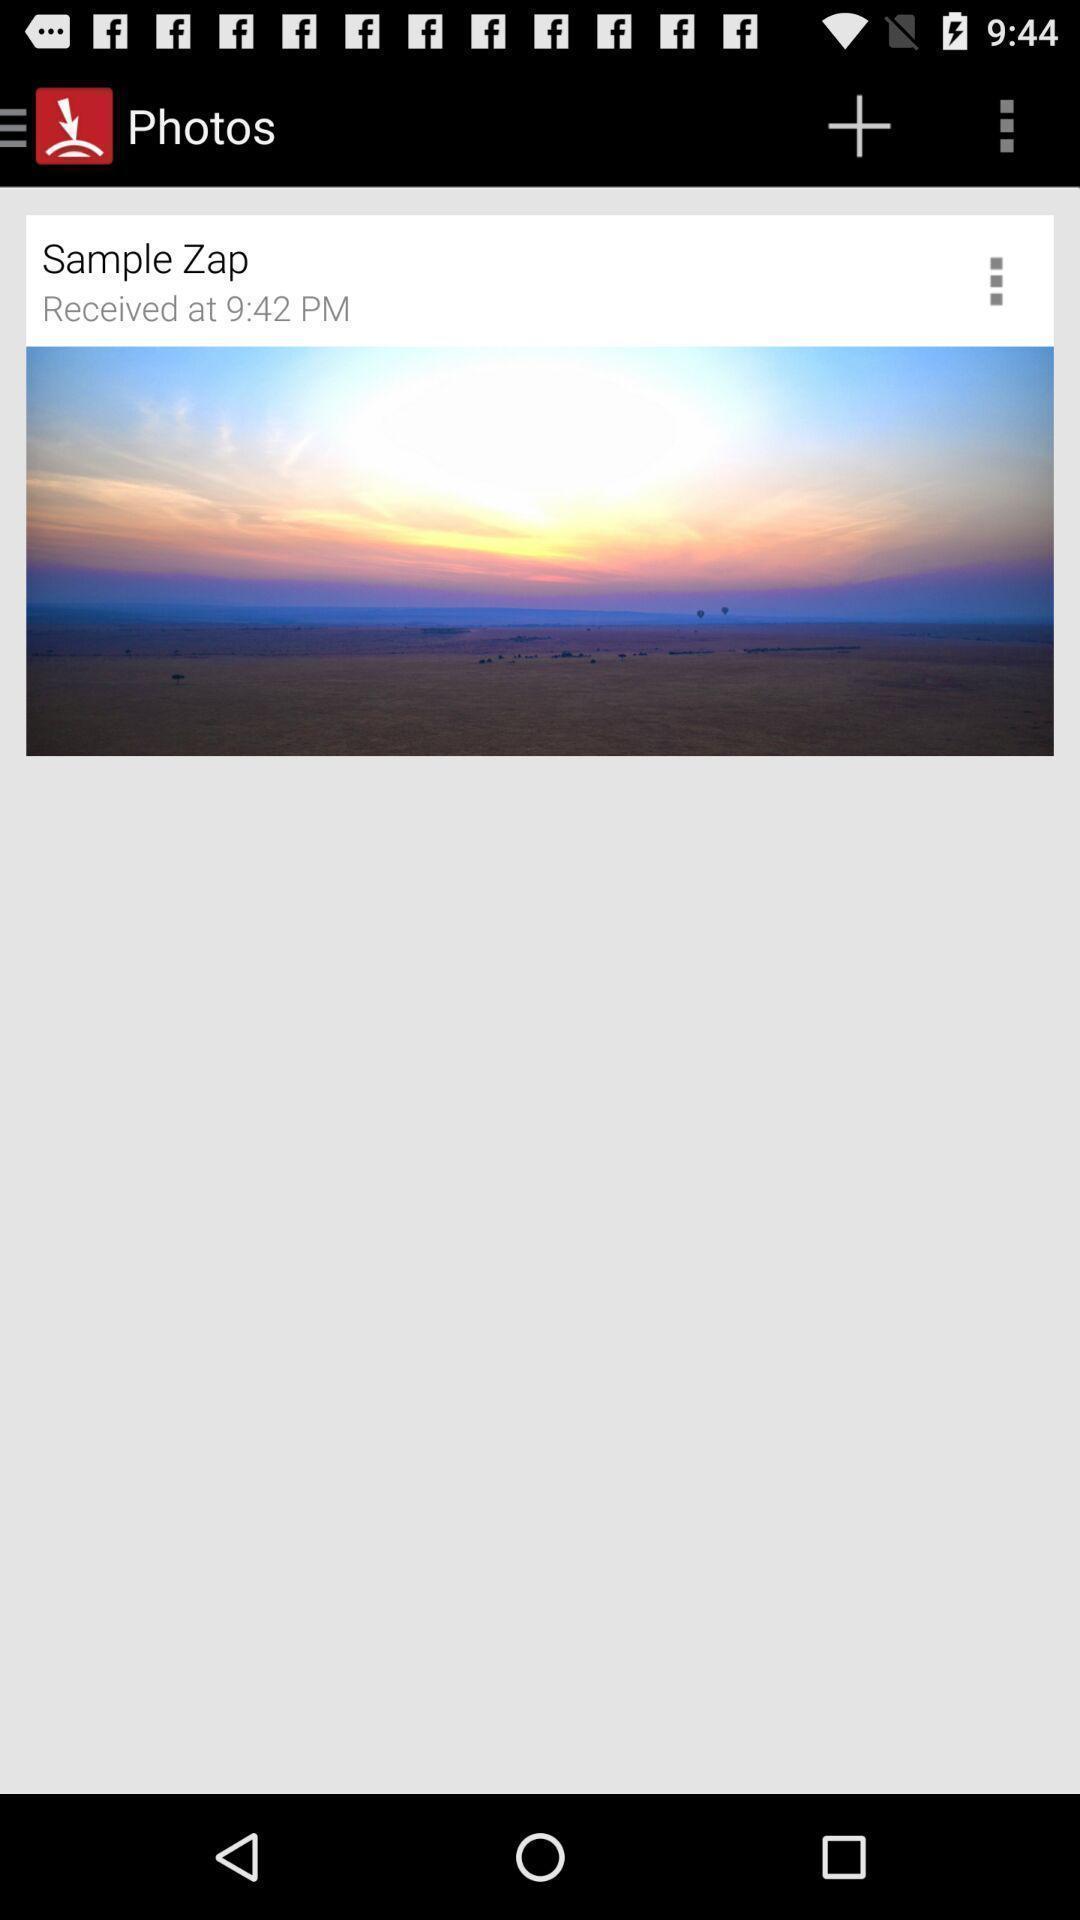Tell me about the visual elements in this screen capture. Window displaying the photos page. 